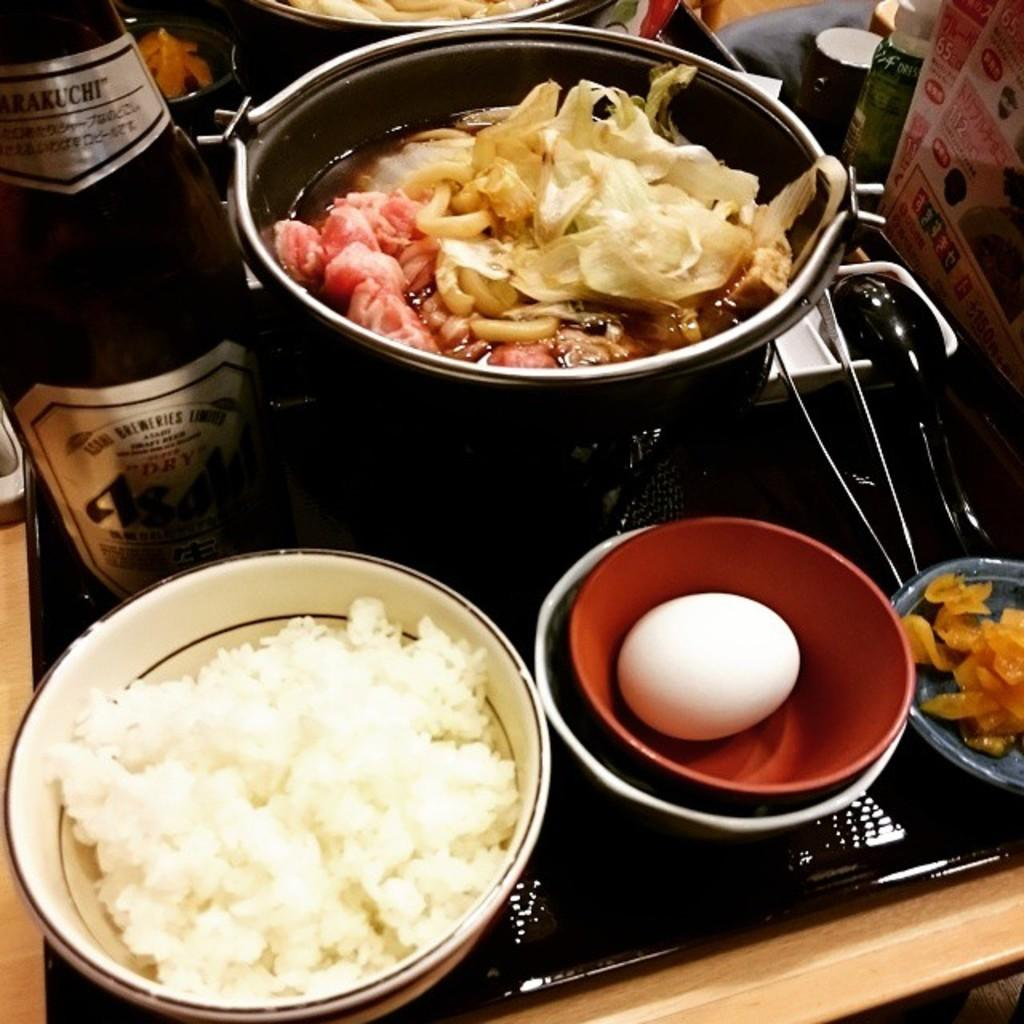<image>
Create a compact narrative representing the image presented. A bottle of Asahi beer is next to a Japanese hot pot dish. 